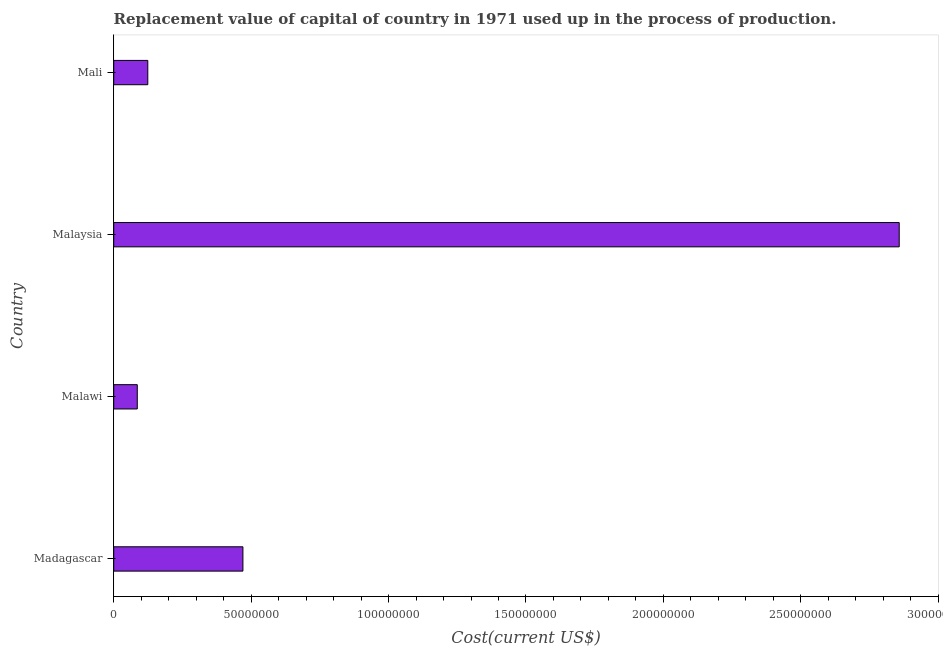Does the graph contain any zero values?
Keep it short and to the point. No. Does the graph contain grids?
Make the answer very short. No. What is the title of the graph?
Your response must be concise. Replacement value of capital of country in 1971 used up in the process of production. What is the label or title of the X-axis?
Your answer should be very brief. Cost(current US$). What is the consumption of fixed capital in Madagascar?
Your answer should be compact. 4.70e+07. Across all countries, what is the maximum consumption of fixed capital?
Provide a short and direct response. 2.86e+08. Across all countries, what is the minimum consumption of fixed capital?
Offer a terse response. 8.56e+06. In which country was the consumption of fixed capital maximum?
Make the answer very short. Malaysia. In which country was the consumption of fixed capital minimum?
Give a very brief answer. Malawi. What is the sum of the consumption of fixed capital?
Give a very brief answer. 3.54e+08. What is the difference between the consumption of fixed capital in Malawi and Malaysia?
Provide a short and direct response. -2.77e+08. What is the average consumption of fixed capital per country?
Keep it short and to the point. 8.84e+07. What is the median consumption of fixed capital?
Your answer should be very brief. 2.97e+07. In how many countries, is the consumption of fixed capital greater than 130000000 US$?
Your response must be concise. 1. What is the ratio of the consumption of fixed capital in Madagascar to that in Malawi?
Keep it short and to the point. 5.49. Is the difference between the consumption of fixed capital in Madagascar and Malawi greater than the difference between any two countries?
Ensure brevity in your answer.  No. What is the difference between the highest and the second highest consumption of fixed capital?
Your answer should be very brief. 2.39e+08. Is the sum of the consumption of fixed capital in Madagascar and Mali greater than the maximum consumption of fixed capital across all countries?
Your answer should be compact. No. What is the difference between the highest and the lowest consumption of fixed capital?
Your answer should be very brief. 2.77e+08. How many bars are there?
Offer a terse response. 4. How many countries are there in the graph?
Keep it short and to the point. 4. What is the Cost(current US$) of Madagascar?
Your answer should be compact. 4.70e+07. What is the Cost(current US$) of Malawi?
Offer a terse response. 8.56e+06. What is the Cost(current US$) in Malaysia?
Give a very brief answer. 2.86e+08. What is the Cost(current US$) in Mali?
Your response must be concise. 1.24e+07. What is the difference between the Cost(current US$) in Madagascar and Malawi?
Give a very brief answer. 3.84e+07. What is the difference between the Cost(current US$) in Madagascar and Malaysia?
Keep it short and to the point. -2.39e+08. What is the difference between the Cost(current US$) in Madagascar and Mali?
Offer a very short reply. 3.46e+07. What is the difference between the Cost(current US$) in Malawi and Malaysia?
Offer a terse response. -2.77e+08. What is the difference between the Cost(current US$) in Malawi and Mali?
Offer a terse response. -3.83e+06. What is the difference between the Cost(current US$) in Malaysia and Mali?
Your answer should be very brief. 2.73e+08. What is the ratio of the Cost(current US$) in Madagascar to that in Malawi?
Provide a succinct answer. 5.49. What is the ratio of the Cost(current US$) in Madagascar to that in Malaysia?
Your response must be concise. 0.16. What is the ratio of the Cost(current US$) in Madagascar to that in Mali?
Your response must be concise. 3.79. What is the ratio of the Cost(current US$) in Malawi to that in Mali?
Keep it short and to the point. 0.69. What is the ratio of the Cost(current US$) in Malaysia to that in Mali?
Your response must be concise. 23.06. 